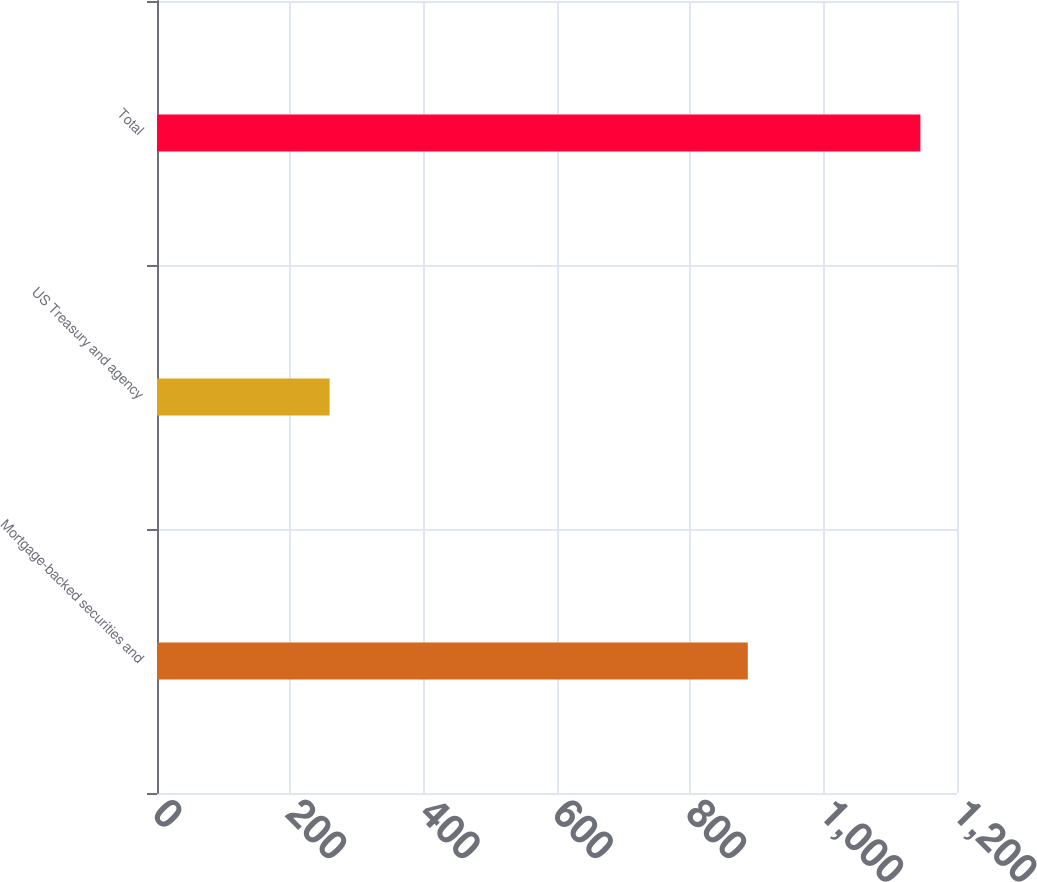Convert chart. <chart><loc_0><loc_0><loc_500><loc_500><bar_chart><fcel>Mortgage-backed securities and<fcel>US Treasury and agency<fcel>Total<nl><fcel>886.2<fcel>258.9<fcel>1145.1<nl></chart> 